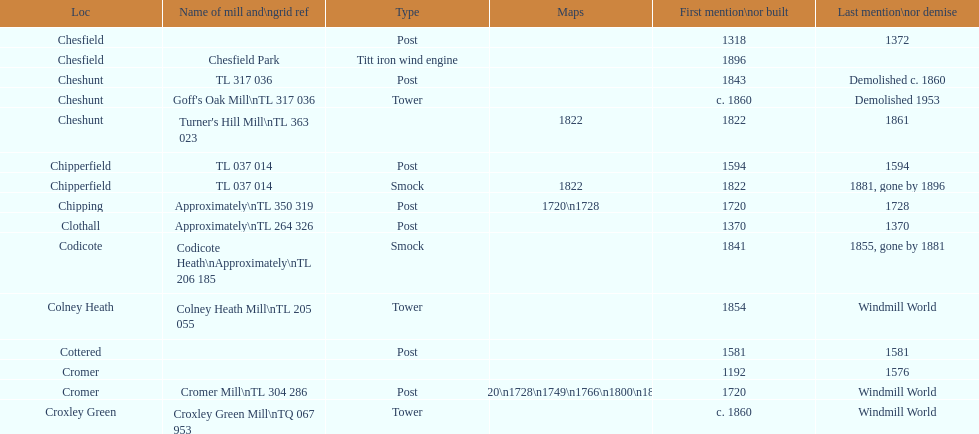What is the sum of all mills named cheshunt? 3. 